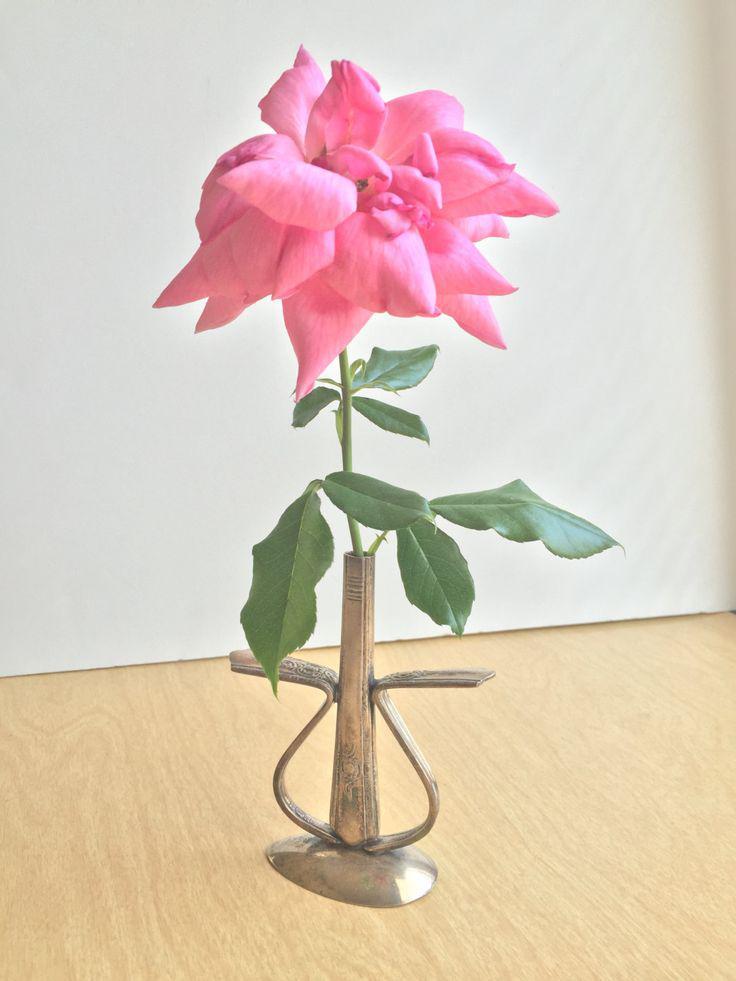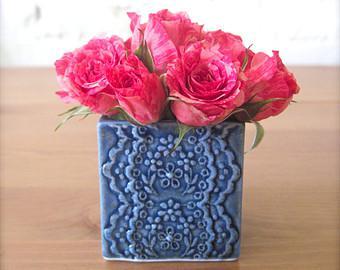The first image is the image on the left, the second image is the image on the right. Examine the images to the left and right. Is the description "There are at least five pink flowers with some green leaves set in a square vase to reveal the top of the flowers." accurate? Answer yes or no. Yes. 